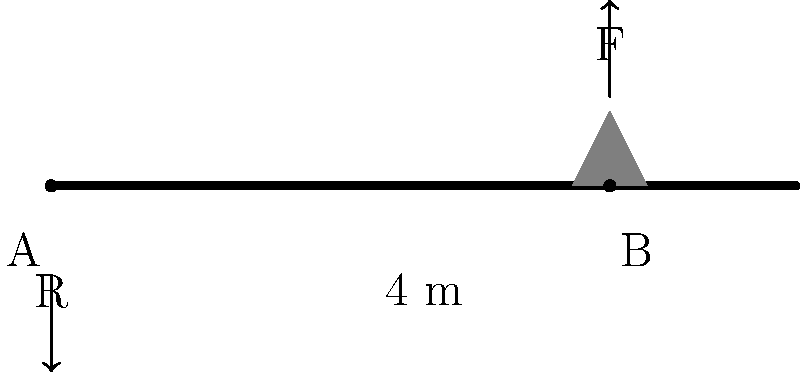A gymnast weighing 500 N is standing on a 4-meter long balance beam, 3 meters from the left support point A. Calculate the magnitude of the torque produced by the gymnast's weight about point A. To solve this problem, we'll follow these steps:

1) First, let's identify the known variables:
   - Weight of the gymnast, $F = 500 \text{ N}$
   - Length of the beam, $L = 4 \text{ m}$
   - Distance of the gymnast from point A, $d = 3 \text{ m}$

2) The torque $\tau$ is defined as the product of the force and the perpendicular distance from the axis of rotation:

   $\tau = F \times d$

3) In this case, the force is the weight of the gymnast (500 N), and the distance is the distance from point A to the gymnast's position (3 m).

4) Substituting these values into the equation:

   $\tau = 500 \text{ N} \times 3 \text{ m}$

5) Calculating:

   $\tau = 1500 \text{ N}\cdot\text{m}$

6) The direction of the torque is clockwise, but the question only asks for the magnitude.

Therefore, the magnitude of the torque produced by the gymnast's weight about point A is 1500 N⋅m.
Answer: 1500 N⋅m 